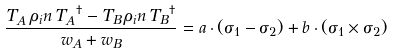Convert formula to latex. <formula><loc_0><loc_0><loc_500><loc_500>\frac { T _ { A } \, \rho _ { i } n \, { T _ { A } } ^ { \dagger } - T _ { B } \, \rho _ { i } n \, { T _ { B } } ^ { \dagger } } { w _ { A } + w _ { B } } = a \cdot ( \sigma _ { 1 } - \sigma _ { 2 } ) + b \cdot ( \sigma _ { 1 } \times \sigma _ { 2 } )</formula> 